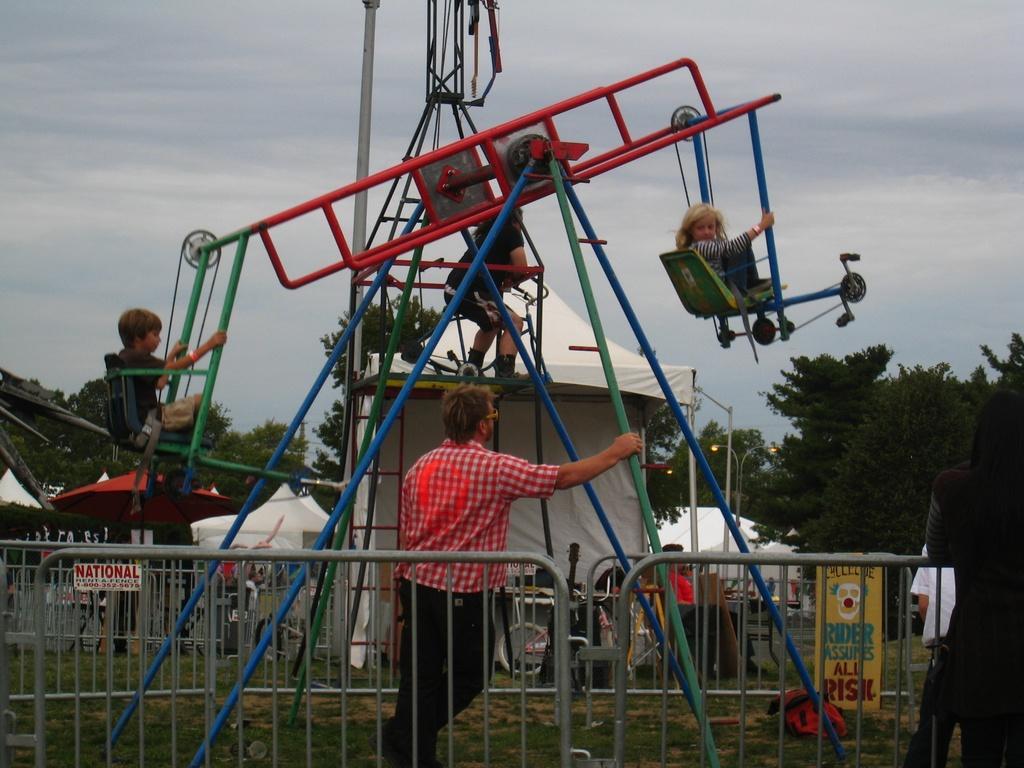How would you summarize this image in a sentence or two? In the middle a man is standing and holding this iron rod, he wore shirt, trouser. Her 3 children are playing by sitting on this. At the back side there are trees, at the top it is a cloudy sky. 